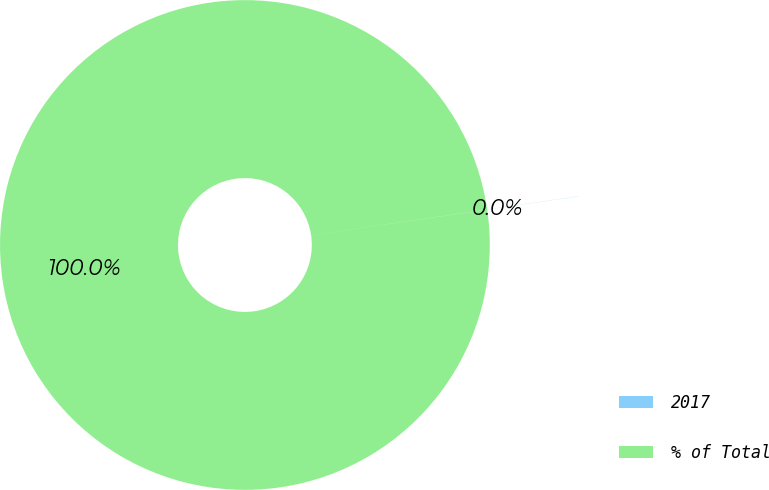Convert chart to OTSL. <chart><loc_0><loc_0><loc_500><loc_500><pie_chart><fcel>2017<fcel>% of Total<nl><fcel>0.01%<fcel>99.99%<nl></chart> 